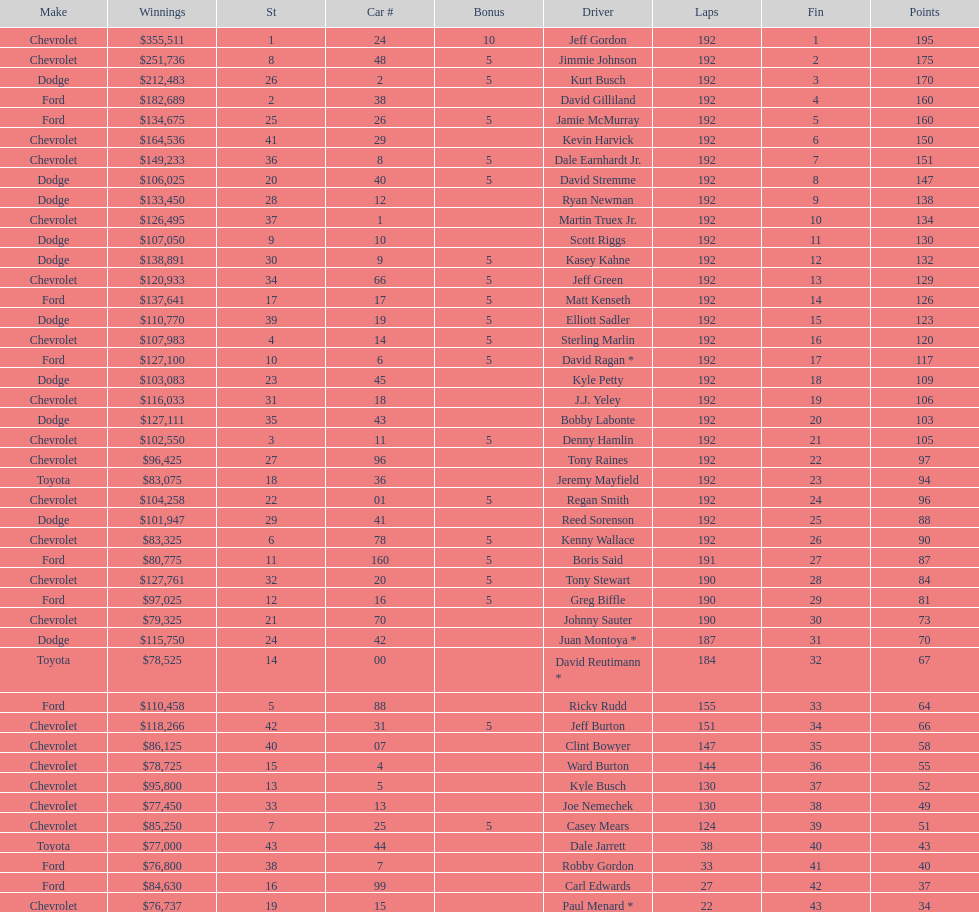Which make had the most consecutive finishes at the aarons 499? Chevrolet. 